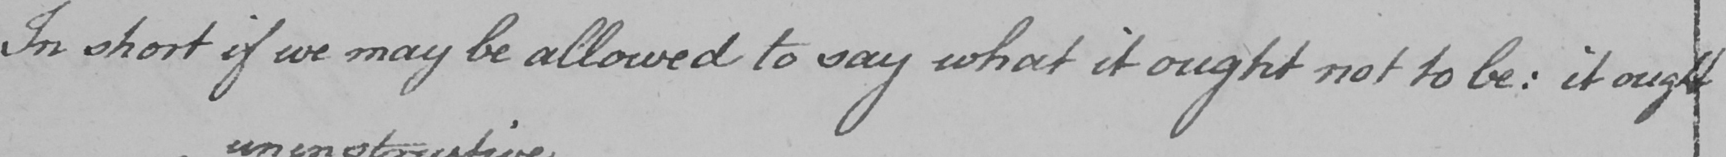Please transcribe the handwritten text in this image. In short if we may be allowed to say what it ought not to be :  it ought 